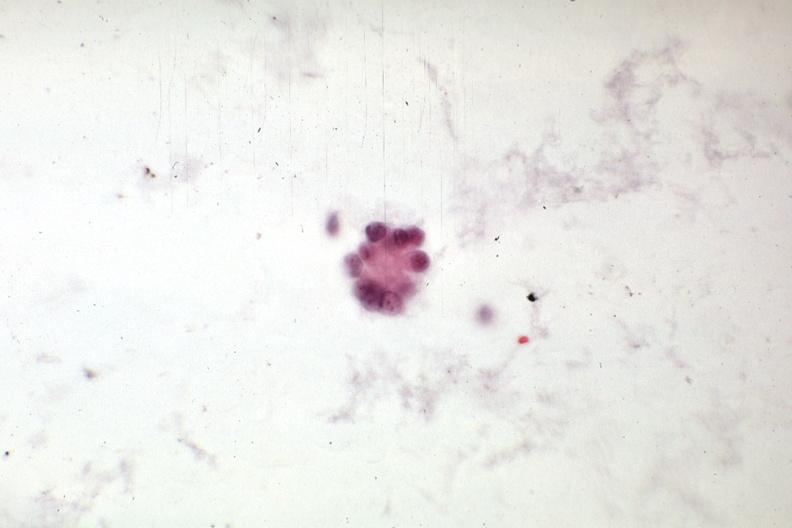what does this image show?
Answer the question using a single word or phrase. Adenocarcinoma from mixed mesodermal uterine tumor 